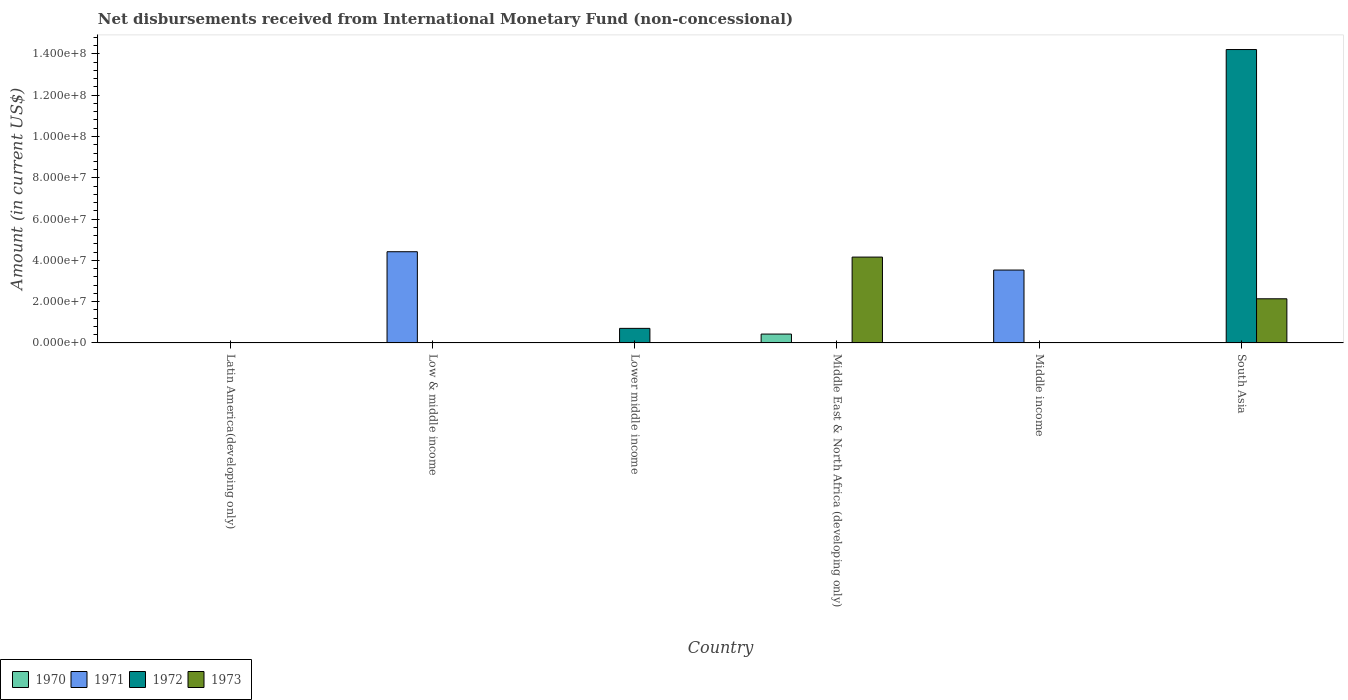How many different coloured bars are there?
Your response must be concise. 4. Are the number of bars on each tick of the X-axis equal?
Provide a short and direct response. No. What is the label of the 3rd group of bars from the left?
Your response must be concise. Lower middle income. In how many cases, is the number of bars for a given country not equal to the number of legend labels?
Your response must be concise. 6. What is the amount of disbursements received from International Monetary Fund in 1973 in South Asia?
Your answer should be very brief. 2.14e+07. Across all countries, what is the maximum amount of disbursements received from International Monetary Fund in 1973?
Provide a succinct answer. 4.16e+07. What is the total amount of disbursements received from International Monetary Fund in 1973 in the graph?
Ensure brevity in your answer.  6.30e+07. What is the difference between the amount of disbursements received from International Monetary Fund in 1971 in Low & middle income and that in Middle income?
Make the answer very short. 8.88e+06. What is the difference between the amount of disbursements received from International Monetary Fund in 1970 in Latin America(developing only) and the amount of disbursements received from International Monetary Fund in 1971 in Middle income?
Keep it short and to the point. -3.53e+07. What is the average amount of disbursements received from International Monetary Fund in 1972 per country?
Your answer should be compact. 2.49e+07. What is the difference between the highest and the lowest amount of disbursements received from International Monetary Fund in 1971?
Give a very brief answer. 4.42e+07. In how many countries, is the amount of disbursements received from International Monetary Fund in 1972 greater than the average amount of disbursements received from International Monetary Fund in 1972 taken over all countries?
Your response must be concise. 1. Is it the case that in every country, the sum of the amount of disbursements received from International Monetary Fund in 1971 and amount of disbursements received from International Monetary Fund in 1970 is greater than the sum of amount of disbursements received from International Monetary Fund in 1973 and amount of disbursements received from International Monetary Fund in 1972?
Your response must be concise. No. How many countries are there in the graph?
Provide a short and direct response. 6. What is the difference between two consecutive major ticks on the Y-axis?
Your answer should be very brief. 2.00e+07. Are the values on the major ticks of Y-axis written in scientific E-notation?
Your answer should be compact. Yes. Does the graph contain any zero values?
Give a very brief answer. Yes. Where does the legend appear in the graph?
Your response must be concise. Bottom left. How are the legend labels stacked?
Ensure brevity in your answer.  Horizontal. What is the title of the graph?
Your answer should be compact. Net disbursements received from International Monetary Fund (non-concessional). What is the label or title of the X-axis?
Your answer should be compact. Country. What is the label or title of the Y-axis?
Your answer should be very brief. Amount (in current US$). What is the Amount (in current US$) in 1972 in Latin America(developing only)?
Your answer should be compact. 0. What is the Amount (in current US$) of 1973 in Latin America(developing only)?
Provide a short and direct response. 0. What is the Amount (in current US$) in 1970 in Low & middle income?
Provide a short and direct response. 0. What is the Amount (in current US$) in 1971 in Low & middle income?
Your response must be concise. 4.42e+07. What is the Amount (in current US$) of 1972 in Low & middle income?
Your response must be concise. 0. What is the Amount (in current US$) in 1973 in Low & middle income?
Give a very brief answer. 0. What is the Amount (in current US$) of 1970 in Lower middle income?
Offer a very short reply. 0. What is the Amount (in current US$) of 1972 in Lower middle income?
Your response must be concise. 7.06e+06. What is the Amount (in current US$) in 1973 in Lower middle income?
Keep it short and to the point. 0. What is the Amount (in current US$) in 1970 in Middle East & North Africa (developing only)?
Your answer should be very brief. 4.30e+06. What is the Amount (in current US$) of 1973 in Middle East & North Africa (developing only)?
Your answer should be compact. 4.16e+07. What is the Amount (in current US$) of 1970 in Middle income?
Give a very brief answer. 0. What is the Amount (in current US$) in 1971 in Middle income?
Your answer should be very brief. 3.53e+07. What is the Amount (in current US$) in 1972 in Middle income?
Provide a succinct answer. 0. What is the Amount (in current US$) of 1970 in South Asia?
Ensure brevity in your answer.  0. What is the Amount (in current US$) of 1972 in South Asia?
Provide a short and direct response. 1.42e+08. What is the Amount (in current US$) in 1973 in South Asia?
Your answer should be compact. 2.14e+07. Across all countries, what is the maximum Amount (in current US$) of 1970?
Your answer should be compact. 4.30e+06. Across all countries, what is the maximum Amount (in current US$) in 1971?
Ensure brevity in your answer.  4.42e+07. Across all countries, what is the maximum Amount (in current US$) in 1972?
Give a very brief answer. 1.42e+08. Across all countries, what is the maximum Amount (in current US$) of 1973?
Provide a short and direct response. 4.16e+07. Across all countries, what is the minimum Amount (in current US$) in 1970?
Offer a terse response. 0. What is the total Amount (in current US$) in 1970 in the graph?
Provide a short and direct response. 4.30e+06. What is the total Amount (in current US$) in 1971 in the graph?
Ensure brevity in your answer.  7.95e+07. What is the total Amount (in current US$) of 1972 in the graph?
Give a very brief answer. 1.49e+08. What is the total Amount (in current US$) in 1973 in the graph?
Keep it short and to the point. 6.30e+07. What is the difference between the Amount (in current US$) of 1971 in Low & middle income and that in Middle income?
Your answer should be compact. 8.88e+06. What is the difference between the Amount (in current US$) in 1972 in Lower middle income and that in South Asia?
Give a very brief answer. -1.35e+08. What is the difference between the Amount (in current US$) of 1973 in Middle East & North Africa (developing only) and that in South Asia?
Offer a very short reply. 2.02e+07. What is the difference between the Amount (in current US$) in 1971 in Low & middle income and the Amount (in current US$) in 1972 in Lower middle income?
Make the answer very short. 3.71e+07. What is the difference between the Amount (in current US$) in 1971 in Low & middle income and the Amount (in current US$) in 1973 in Middle East & North Africa (developing only)?
Your response must be concise. 2.60e+06. What is the difference between the Amount (in current US$) of 1971 in Low & middle income and the Amount (in current US$) of 1972 in South Asia?
Your answer should be very brief. -9.79e+07. What is the difference between the Amount (in current US$) of 1971 in Low & middle income and the Amount (in current US$) of 1973 in South Asia?
Ensure brevity in your answer.  2.28e+07. What is the difference between the Amount (in current US$) in 1972 in Lower middle income and the Amount (in current US$) in 1973 in Middle East & North Africa (developing only)?
Ensure brevity in your answer.  -3.45e+07. What is the difference between the Amount (in current US$) in 1972 in Lower middle income and the Amount (in current US$) in 1973 in South Asia?
Your answer should be compact. -1.43e+07. What is the difference between the Amount (in current US$) of 1970 in Middle East & North Africa (developing only) and the Amount (in current US$) of 1971 in Middle income?
Offer a very short reply. -3.10e+07. What is the difference between the Amount (in current US$) in 1970 in Middle East & North Africa (developing only) and the Amount (in current US$) in 1972 in South Asia?
Your answer should be compact. -1.38e+08. What is the difference between the Amount (in current US$) in 1970 in Middle East & North Africa (developing only) and the Amount (in current US$) in 1973 in South Asia?
Your answer should be very brief. -1.71e+07. What is the difference between the Amount (in current US$) of 1971 in Middle income and the Amount (in current US$) of 1972 in South Asia?
Ensure brevity in your answer.  -1.07e+08. What is the difference between the Amount (in current US$) of 1971 in Middle income and the Amount (in current US$) of 1973 in South Asia?
Keep it short and to the point. 1.39e+07. What is the average Amount (in current US$) of 1970 per country?
Offer a terse response. 7.17e+05. What is the average Amount (in current US$) of 1971 per country?
Keep it short and to the point. 1.32e+07. What is the average Amount (in current US$) of 1972 per country?
Your answer should be compact. 2.49e+07. What is the average Amount (in current US$) of 1973 per country?
Ensure brevity in your answer.  1.05e+07. What is the difference between the Amount (in current US$) in 1970 and Amount (in current US$) in 1973 in Middle East & North Africa (developing only)?
Provide a succinct answer. -3.73e+07. What is the difference between the Amount (in current US$) in 1972 and Amount (in current US$) in 1973 in South Asia?
Ensure brevity in your answer.  1.21e+08. What is the ratio of the Amount (in current US$) of 1971 in Low & middle income to that in Middle income?
Offer a very short reply. 1.25. What is the ratio of the Amount (in current US$) of 1972 in Lower middle income to that in South Asia?
Your answer should be compact. 0.05. What is the ratio of the Amount (in current US$) in 1973 in Middle East & North Africa (developing only) to that in South Asia?
Provide a succinct answer. 1.94. What is the difference between the highest and the lowest Amount (in current US$) of 1970?
Provide a short and direct response. 4.30e+06. What is the difference between the highest and the lowest Amount (in current US$) of 1971?
Provide a succinct answer. 4.42e+07. What is the difference between the highest and the lowest Amount (in current US$) in 1972?
Your response must be concise. 1.42e+08. What is the difference between the highest and the lowest Amount (in current US$) in 1973?
Your answer should be compact. 4.16e+07. 